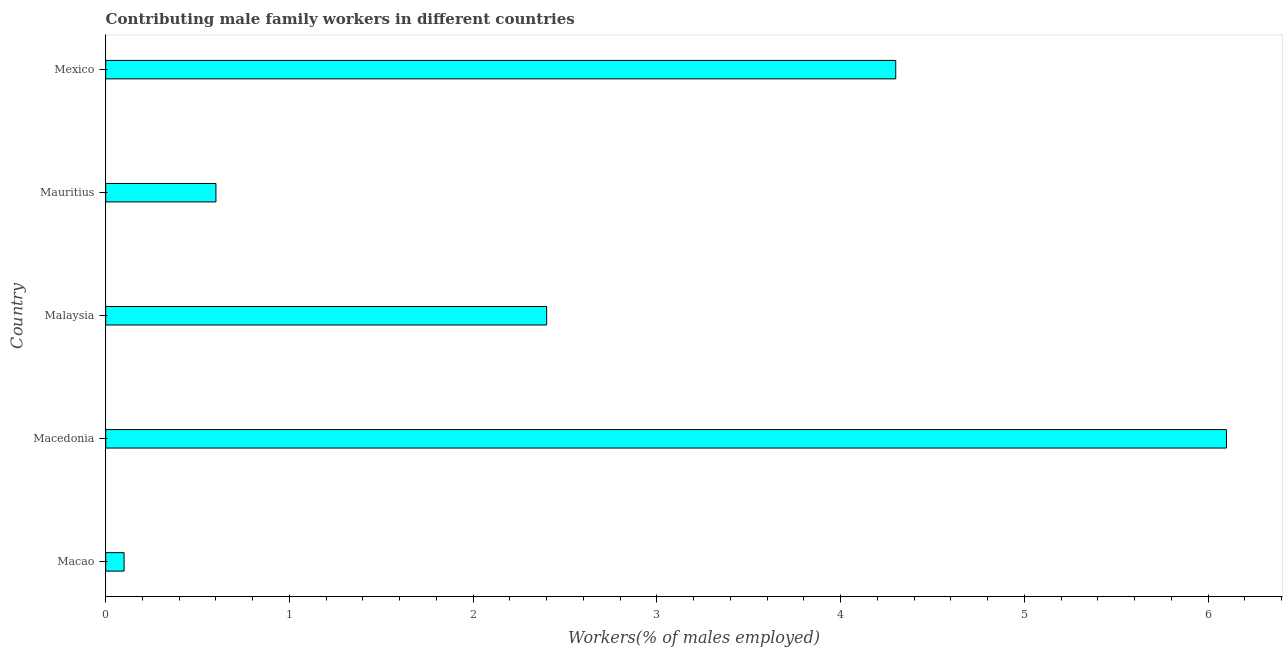Does the graph contain any zero values?
Your answer should be very brief. No. What is the title of the graph?
Make the answer very short. Contributing male family workers in different countries. What is the label or title of the X-axis?
Your answer should be very brief. Workers(% of males employed). What is the label or title of the Y-axis?
Provide a succinct answer. Country. What is the contributing male family workers in Malaysia?
Provide a short and direct response. 2.4. Across all countries, what is the maximum contributing male family workers?
Make the answer very short. 6.1. Across all countries, what is the minimum contributing male family workers?
Offer a terse response. 0.1. In which country was the contributing male family workers maximum?
Provide a short and direct response. Macedonia. In which country was the contributing male family workers minimum?
Your response must be concise. Macao. What is the sum of the contributing male family workers?
Your answer should be very brief. 13.5. What is the difference between the contributing male family workers in Macedonia and Malaysia?
Provide a succinct answer. 3.7. What is the average contributing male family workers per country?
Offer a terse response. 2.7. What is the median contributing male family workers?
Give a very brief answer. 2.4. In how many countries, is the contributing male family workers greater than 4.8 %?
Make the answer very short. 1. What is the ratio of the contributing male family workers in Mauritius to that in Mexico?
Offer a terse response. 0.14. What is the difference between the highest and the second highest contributing male family workers?
Keep it short and to the point. 1.8. Is the sum of the contributing male family workers in Macao and Malaysia greater than the maximum contributing male family workers across all countries?
Provide a short and direct response. No. Are all the bars in the graph horizontal?
Keep it short and to the point. Yes. How many countries are there in the graph?
Offer a terse response. 5. Are the values on the major ticks of X-axis written in scientific E-notation?
Keep it short and to the point. No. What is the Workers(% of males employed) in Macao?
Your answer should be compact. 0.1. What is the Workers(% of males employed) in Macedonia?
Offer a terse response. 6.1. What is the Workers(% of males employed) in Malaysia?
Give a very brief answer. 2.4. What is the Workers(% of males employed) in Mauritius?
Your answer should be very brief. 0.6. What is the Workers(% of males employed) in Mexico?
Offer a very short reply. 4.3. What is the difference between the Workers(% of males employed) in Macao and Mexico?
Offer a very short reply. -4.2. What is the difference between the Workers(% of males employed) in Macedonia and Malaysia?
Make the answer very short. 3.7. What is the difference between the Workers(% of males employed) in Macedonia and Mauritius?
Offer a terse response. 5.5. What is the difference between the Workers(% of males employed) in Macedonia and Mexico?
Offer a terse response. 1.8. What is the difference between the Workers(% of males employed) in Mauritius and Mexico?
Provide a short and direct response. -3.7. What is the ratio of the Workers(% of males employed) in Macao to that in Macedonia?
Keep it short and to the point. 0.02. What is the ratio of the Workers(% of males employed) in Macao to that in Malaysia?
Your answer should be very brief. 0.04. What is the ratio of the Workers(% of males employed) in Macao to that in Mauritius?
Make the answer very short. 0.17. What is the ratio of the Workers(% of males employed) in Macao to that in Mexico?
Give a very brief answer. 0.02. What is the ratio of the Workers(% of males employed) in Macedonia to that in Malaysia?
Make the answer very short. 2.54. What is the ratio of the Workers(% of males employed) in Macedonia to that in Mauritius?
Your answer should be very brief. 10.17. What is the ratio of the Workers(% of males employed) in Macedonia to that in Mexico?
Give a very brief answer. 1.42. What is the ratio of the Workers(% of males employed) in Malaysia to that in Mauritius?
Provide a succinct answer. 4. What is the ratio of the Workers(% of males employed) in Malaysia to that in Mexico?
Keep it short and to the point. 0.56. What is the ratio of the Workers(% of males employed) in Mauritius to that in Mexico?
Offer a very short reply. 0.14. 